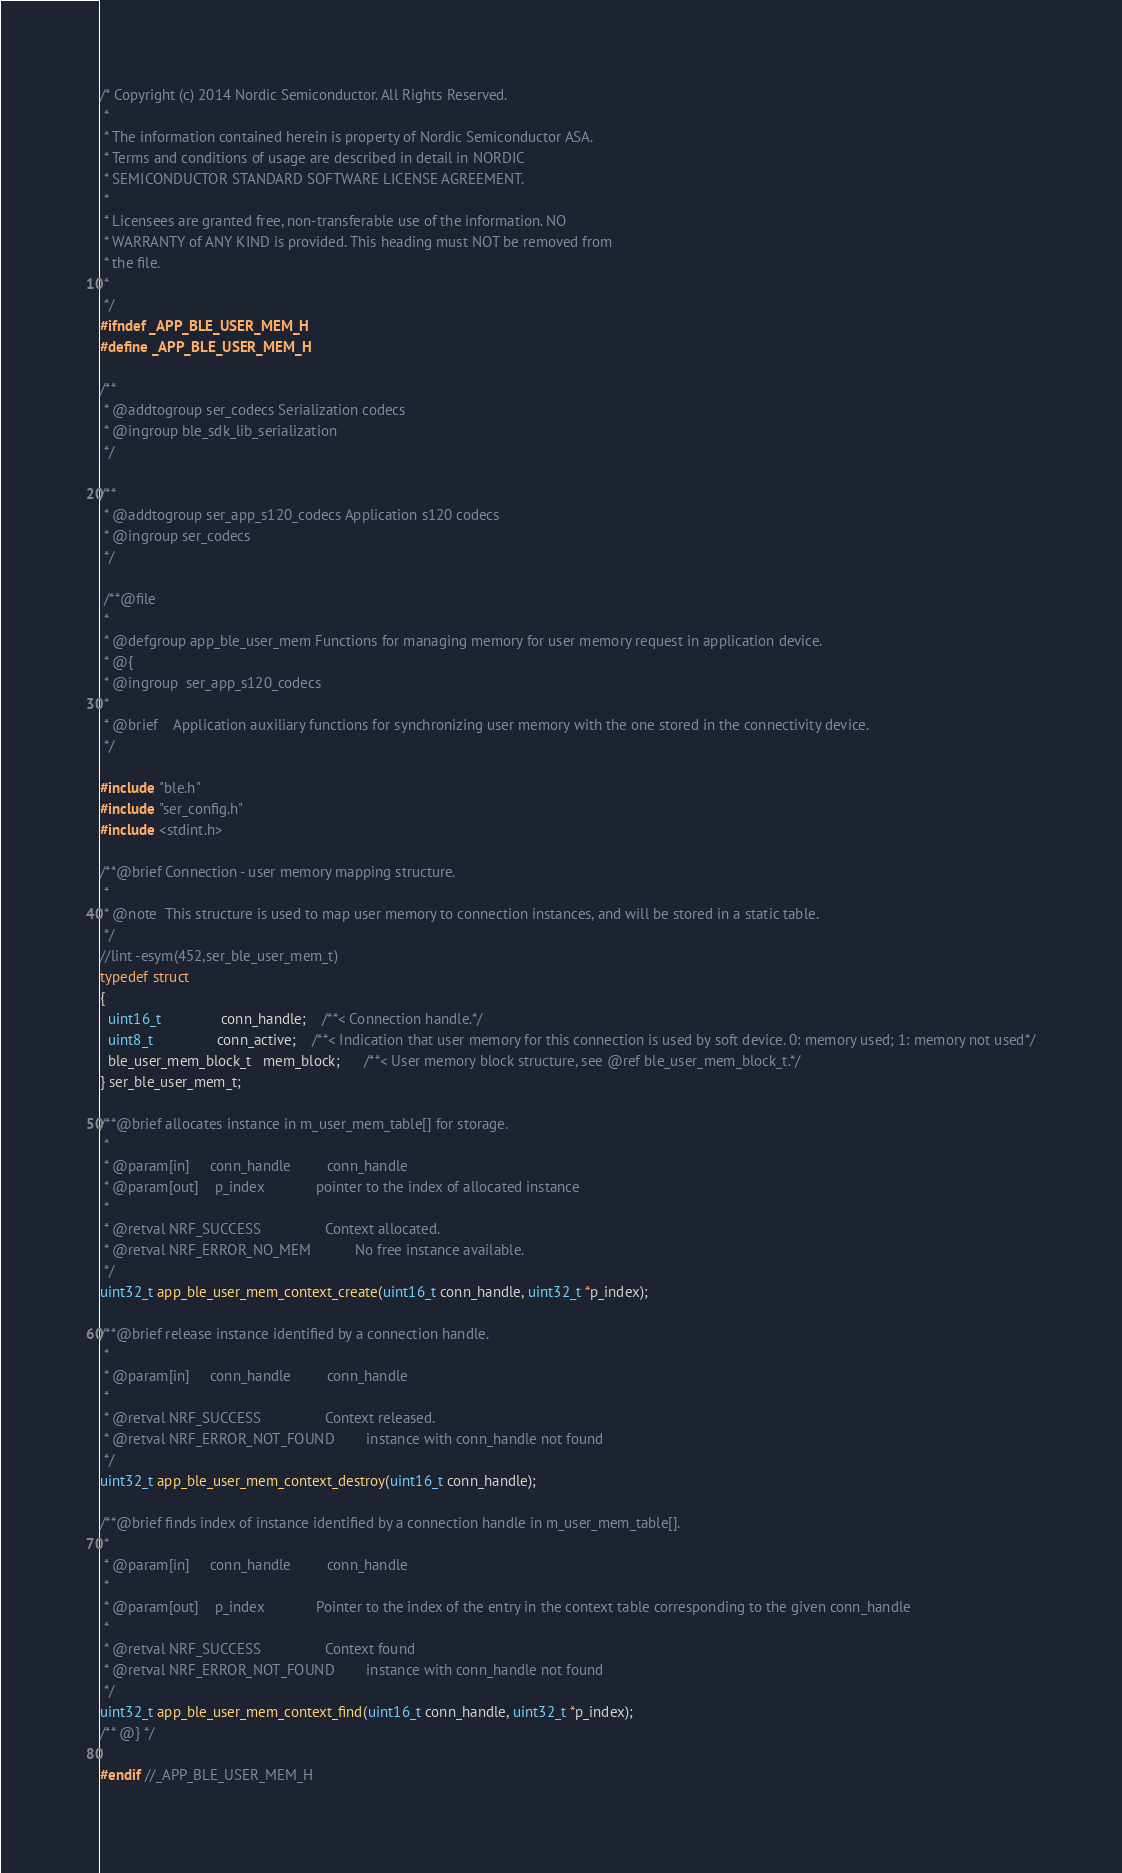Convert code to text. <code><loc_0><loc_0><loc_500><loc_500><_C_>/* Copyright (c) 2014 Nordic Semiconductor. All Rights Reserved.
 *
 * The information contained herein is property of Nordic Semiconductor ASA.
 * Terms and conditions of usage are described in detail in NORDIC
 * SEMICONDUCTOR STANDARD SOFTWARE LICENSE AGREEMENT.
 *
 * Licensees are granted free, non-transferable use of the information. NO
 * WARRANTY of ANY KIND is provided. This heading must NOT be removed from
 * the file.
 *
 */
#ifndef _APP_BLE_USER_MEM_H
#define _APP_BLE_USER_MEM_H

/**
 * @addtogroup ser_codecs Serialization codecs
 * @ingroup ble_sdk_lib_serialization
 */

/**
 * @addtogroup ser_app_s120_codecs Application s120 codecs
 * @ingroup ser_codecs
 */

 /**@file
 *
 * @defgroup app_ble_user_mem Functions for managing memory for user memory request in application device.
 * @{
 * @ingroup  ser_app_s120_codecs
 *
 * @brief    Application auxiliary functions for synchronizing user memory with the one stored in the connectivity device. 
 */

#include "ble.h"
#include "ser_config.h"
#include <stdint.h>

/**@brief Connection - user memory mapping structure.
 *
 * @note  This structure is used to map user memory to connection instances, and will be stored in a static table.
 */
//lint -esym(452,ser_ble_user_mem_t) 
typedef struct
{
  uint16_t               conn_handle;    /**< Connection handle.*/
  uint8_t                conn_active;    /**< Indication that user memory for this connection is used by soft device. 0: memory used; 1: memory not used*/
  ble_user_mem_block_t   mem_block;      /**< User memory block structure, see @ref ble_user_mem_block_t.*/
} ser_ble_user_mem_t;

/**@brief allocates instance in m_user_mem_table[] for storage.
 *
 * @param[in]     conn_handle         conn_handle
 * @param[out]    p_index             pointer to the index of allocated instance
 *
 * @retval NRF_SUCCESS                Context allocated.
 * @retval NRF_ERROR_NO_MEM           No free instance available.
 */
uint32_t app_ble_user_mem_context_create(uint16_t conn_handle, uint32_t *p_index);

/**@brief release instance identified by a connection handle.
 *
 * @param[in]     conn_handle         conn_handle
 *
 * @retval NRF_SUCCESS                Context released.
 * @retval NRF_ERROR_NOT_FOUND        instance with conn_handle not found
 */
uint32_t app_ble_user_mem_context_destroy(uint16_t conn_handle);

/**@brief finds index of instance identified by a connection handle in m_user_mem_table[].
 *
 * @param[in]     conn_handle         conn_handle
 *
 * @param[out]    p_index             Pointer to the index of the entry in the context table corresponding to the given conn_handle
 *
 * @retval NRF_SUCCESS                Context found
 * @retval NRF_ERROR_NOT_FOUND        instance with conn_handle not found
 */
uint32_t app_ble_user_mem_context_find(uint16_t conn_handle, uint32_t *p_index);
/** @} */

#endif //_APP_BLE_USER_MEM_H
</code> 